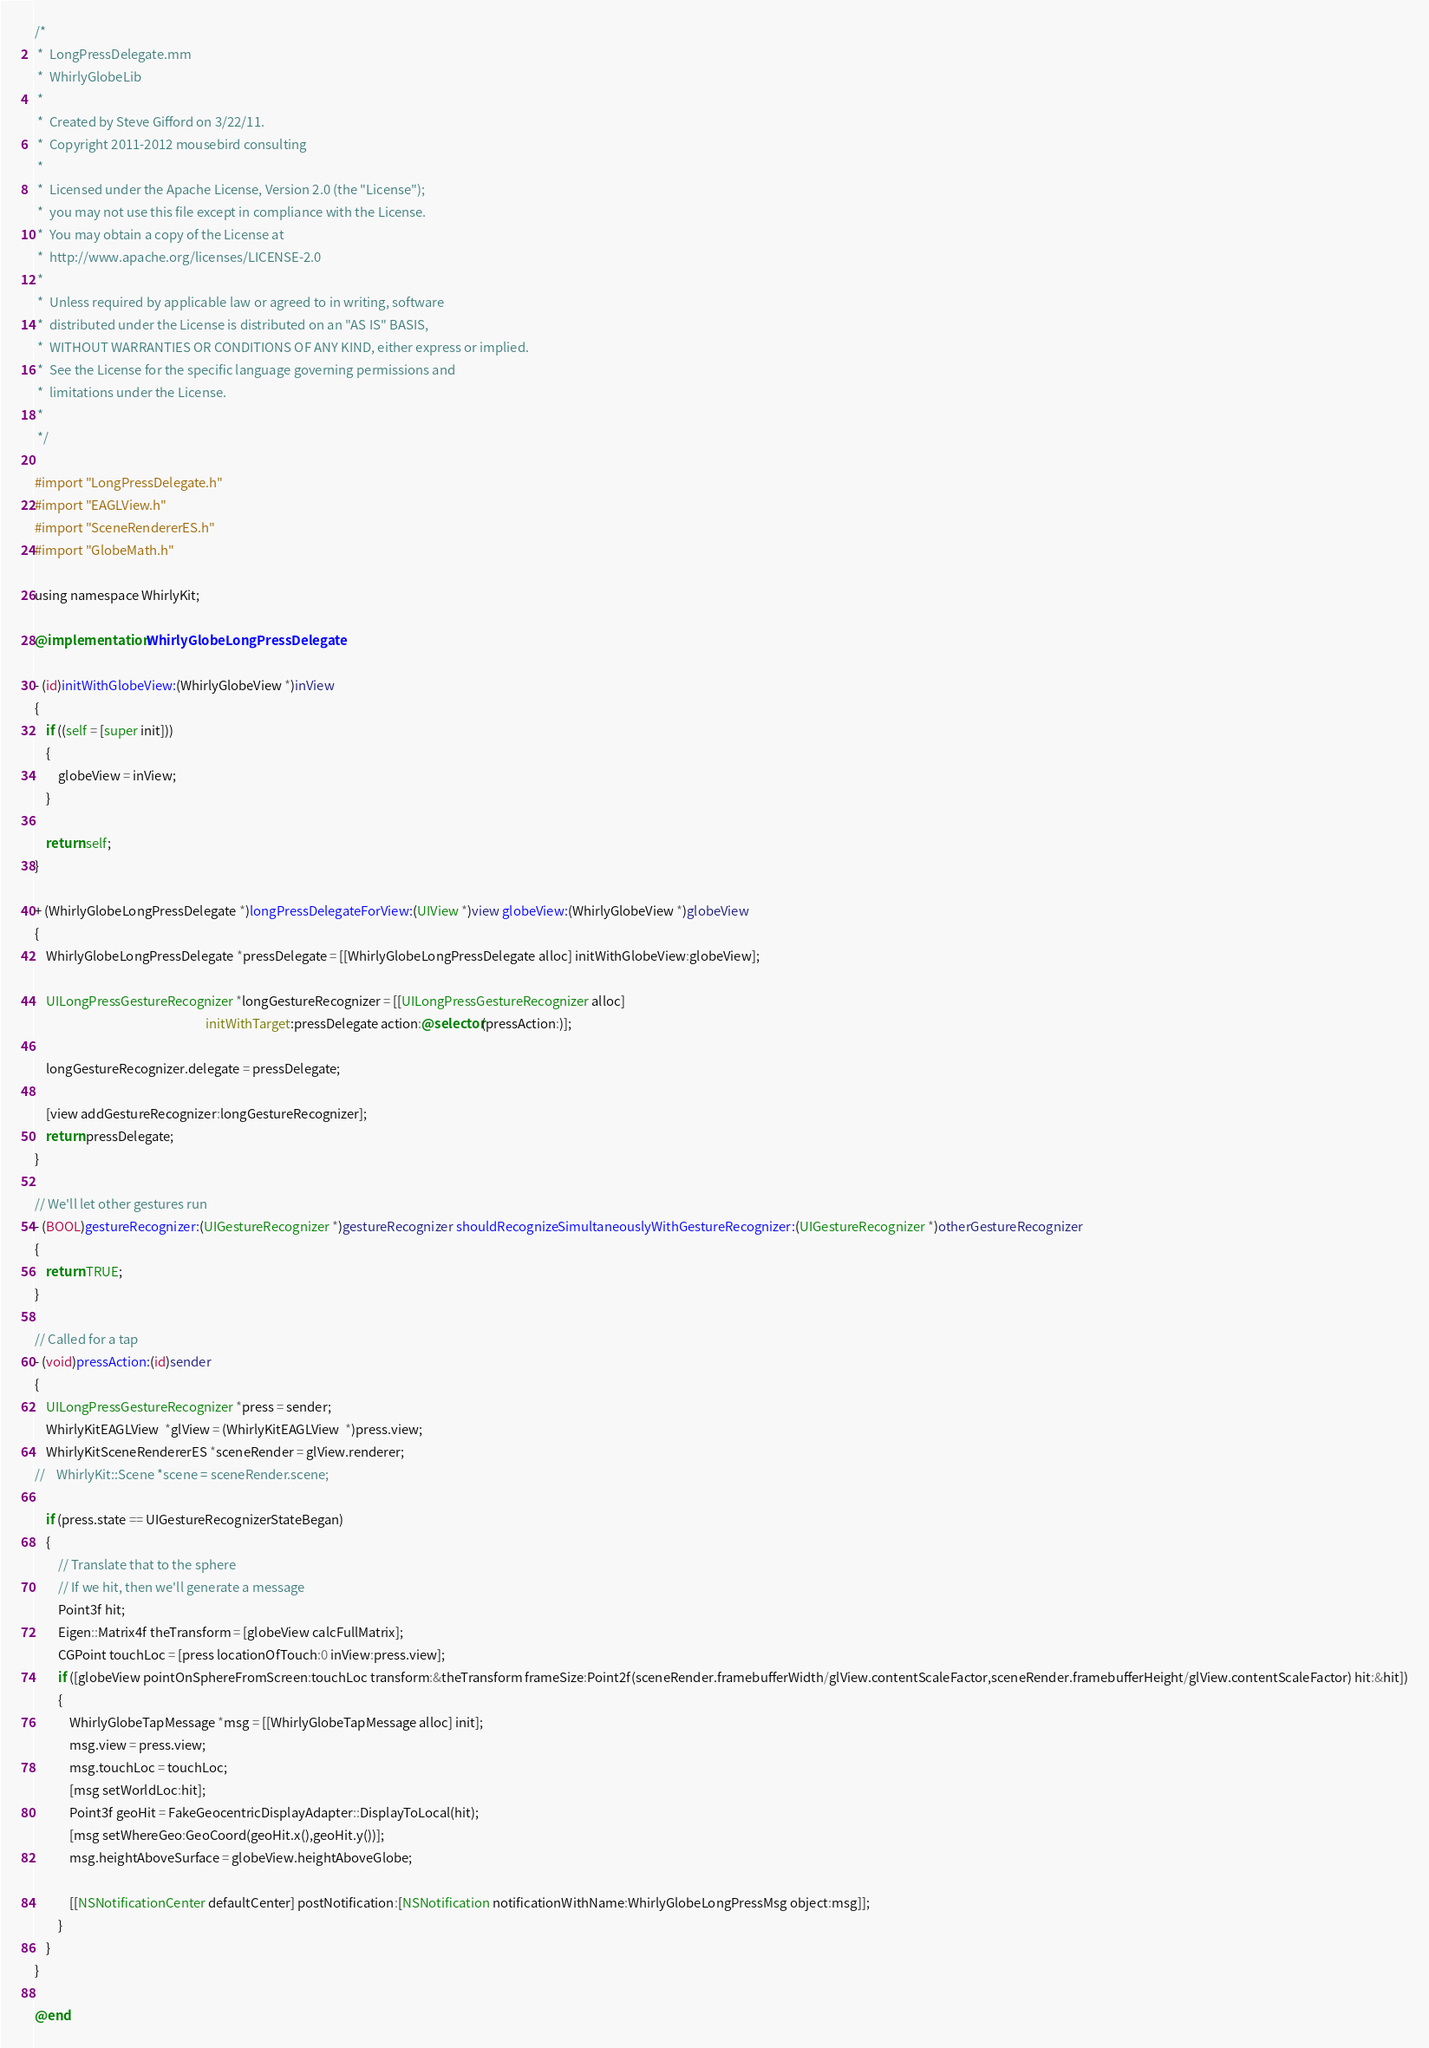Convert code to text. <code><loc_0><loc_0><loc_500><loc_500><_ObjectiveC_>/*
 *  LongPressDelegate.mm
 *  WhirlyGlobeLib
 *
 *  Created by Steve Gifford on 3/22/11.
 *  Copyright 2011-2012 mousebird consulting
 *
 *  Licensed under the Apache License, Version 2.0 (the "License");
 *  you may not use this file except in compliance with the License.
 *  You may obtain a copy of the License at
 *  http://www.apache.org/licenses/LICENSE-2.0
 *
 *  Unless required by applicable law or agreed to in writing, software
 *  distributed under the License is distributed on an "AS IS" BASIS,
 *  WITHOUT WARRANTIES OR CONDITIONS OF ANY KIND, either express or implied.
 *  See the License for the specific language governing permissions and
 *  limitations under the License.
 *
 */

#import "LongPressDelegate.h"
#import "EAGLView.h"
#import "SceneRendererES.h"
#import "GlobeMath.h"

using namespace WhirlyKit;

@implementation WhirlyGlobeLongPressDelegate

- (id)initWithGlobeView:(WhirlyGlobeView *)inView
{
    if ((self = [super init]))
    {
        globeView = inView;
    }
    
    return self;
}

+ (WhirlyGlobeLongPressDelegate *)longPressDelegateForView:(UIView *)view globeView:(WhirlyGlobeView *)globeView
{
    WhirlyGlobeLongPressDelegate *pressDelegate = [[WhirlyGlobeLongPressDelegate alloc] initWithGlobeView:globeView];
    
    UILongPressGestureRecognizer *longGestureRecognizer = [[UILongPressGestureRecognizer alloc]
                                                           initWithTarget:pressDelegate action:@selector(pressAction:)];
    
    longGestureRecognizer.delegate = pressDelegate;
    
    [view addGestureRecognizer:longGestureRecognizer];
    return pressDelegate;
}

// We'll let other gestures run
- (BOOL)gestureRecognizer:(UIGestureRecognizer *)gestureRecognizer shouldRecognizeSimultaneouslyWithGestureRecognizer:(UIGestureRecognizer *)otherGestureRecognizer
{
    return TRUE;
}

// Called for a tap
- (void)pressAction:(id)sender
{
	UILongPressGestureRecognizer *press = sender;
	WhirlyKitEAGLView  *glView = (WhirlyKitEAGLView  *)press.view;
	WhirlyKitSceneRendererES *sceneRender = glView.renderer;
//    WhirlyKit::Scene *scene = sceneRender.scene;
    
    if (press.state == UIGestureRecognizerStateBegan)
    {
        // Translate that to the sphere
        // If we hit, then we'll generate a message
        Point3f hit;
        Eigen::Matrix4f theTransform = [globeView calcFullMatrix];
        CGPoint touchLoc = [press locationOfTouch:0 inView:press.view];
        if ([globeView pointOnSphereFromScreen:touchLoc transform:&theTransform frameSize:Point2f(sceneRender.framebufferWidth/glView.contentScaleFactor,sceneRender.framebufferHeight/glView.contentScaleFactor) hit:&hit])
        {
            WhirlyGlobeTapMessage *msg = [[WhirlyGlobeTapMessage alloc] init];
            msg.view = press.view;
            msg.touchLoc = touchLoc;
            [msg setWorldLoc:hit];
            Point3f geoHit = FakeGeocentricDisplayAdapter::DisplayToLocal(hit);
            [msg setWhereGeo:GeoCoord(geoHit.x(),geoHit.y())];
            msg.heightAboveSurface = globeView.heightAboveGlobe;
            
            [[NSNotificationCenter defaultCenter] postNotification:[NSNotification notificationWithName:WhirlyGlobeLongPressMsg object:msg]];
        }
    }
}

@end
</code> 